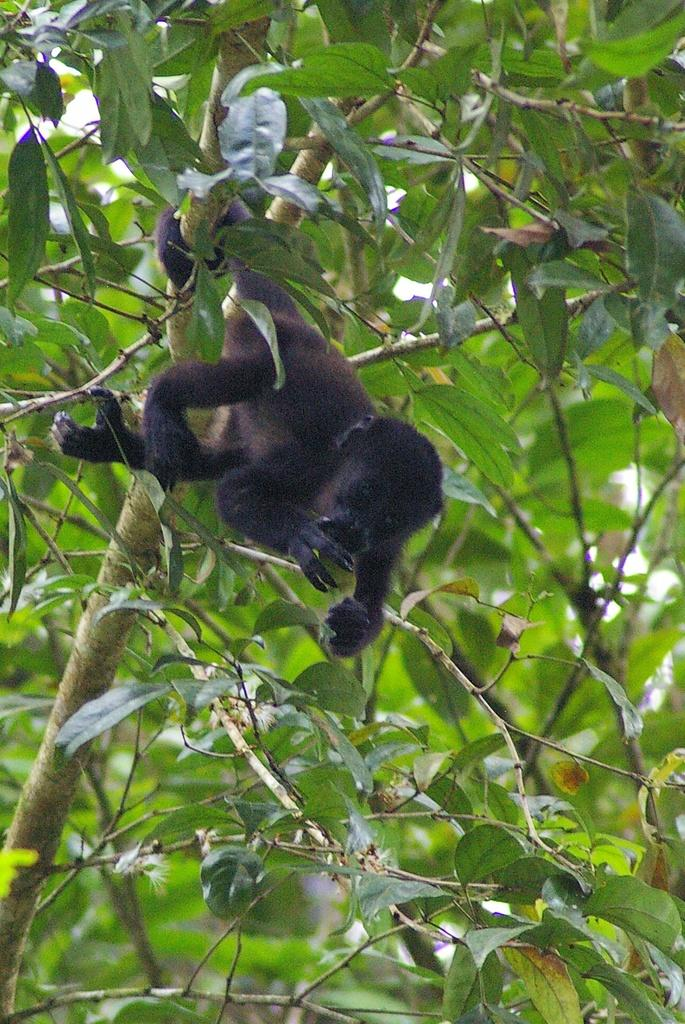What type of creature can be seen in the image? There is an animal in the image. Where is the animal located? The animal is on the branch of a tree. What type of organization is responsible for the exchange of connections in the image? There is no organization, exchange, or connections present in the image; it features an animal on a tree branch. 